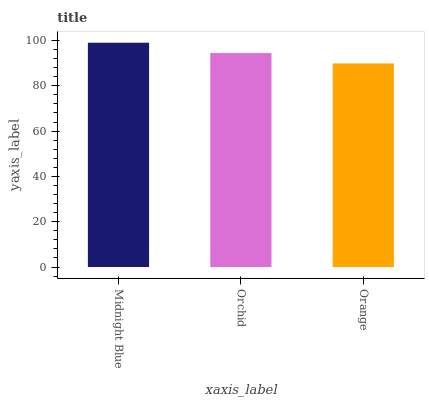Is Orange the minimum?
Answer yes or no. Yes. Is Midnight Blue the maximum?
Answer yes or no. Yes. Is Orchid the minimum?
Answer yes or no. No. Is Orchid the maximum?
Answer yes or no. No. Is Midnight Blue greater than Orchid?
Answer yes or no. Yes. Is Orchid less than Midnight Blue?
Answer yes or no. Yes. Is Orchid greater than Midnight Blue?
Answer yes or no. No. Is Midnight Blue less than Orchid?
Answer yes or no. No. Is Orchid the high median?
Answer yes or no. Yes. Is Orchid the low median?
Answer yes or no. Yes. Is Orange the high median?
Answer yes or no. No. Is Orange the low median?
Answer yes or no. No. 